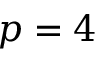<formula> <loc_0><loc_0><loc_500><loc_500>p = 4</formula> 